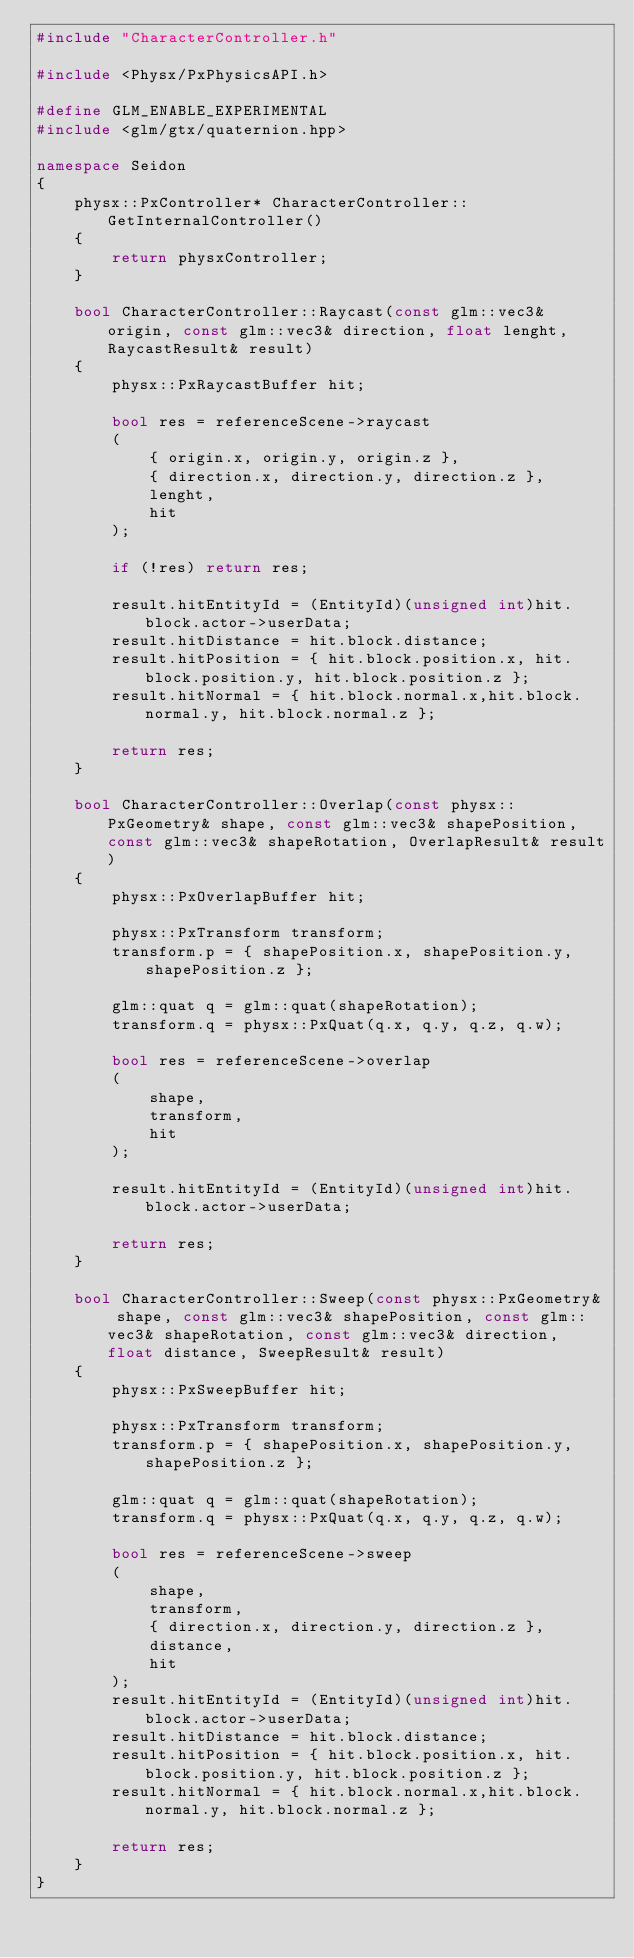<code> <loc_0><loc_0><loc_500><loc_500><_C++_>#include "CharacterController.h"

#include <Physx/PxPhysicsAPI.h>

#define GLM_ENABLE_EXPERIMENTAL
#include <glm/gtx/quaternion.hpp>

namespace Seidon
{
	physx::PxController* CharacterController::GetInternalController()
	{
		return physxController;
	}

	bool CharacterController::Raycast(const glm::vec3& origin, const glm::vec3& direction, float lenght, RaycastResult& result)
	{
		physx::PxRaycastBuffer hit;

		bool res = referenceScene->raycast
		(
			{ origin.x, origin.y, origin.z },
			{ direction.x, direction.y, direction.z },
			lenght,
			hit
		);

		if (!res) return res;

		result.hitEntityId = (EntityId)(unsigned int)hit.block.actor->userData;
		result.hitDistance = hit.block.distance;
		result.hitPosition = { hit.block.position.x, hit.block.position.y, hit.block.position.z };
		result.hitNormal = { hit.block.normal.x,hit.block.normal.y, hit.block.normal.z };

		return res;
	}

	bool CharacterController::Overlap(const physx::PxGeometry& shape, const glm::vec3& shapePosition, const glm::vec3& shapeRotation, OverlapResult& result)
	{
		physx::PxOverlapBuffer hit;

		physx::PxTransform transform;
		transform.p = { shapePosition.x, shapePosition.y, shapePosition.z };

		glm::quat q = glm::quat(shapeRotation);
		transform.q = physx::PxQuat(q.x, q.y, q.z, q.w);

		bool res = referenceScene->overlap
		(
			shape,
			transform,
			hit
		);

		result.hitEntityId = (EntityId)(unsigned int)hit.block.actor->userData;

		return res;
	}

	bool CharacterController::Sweep(const physx::PxGeometry& shape, const glm::vec3& shapePosition, const glm::vec3& shapeRotation, const glm::vec3& direction, float distance, SweepResult& result)
	{
		physx::PxSweepBuffer hit;

		physx::PxTransform transform;
		transform.p = { shapePosition.x, shapePosition.y, shapePosition.z };

		glm::quat q = glm::quat(shapeRotation);
		transform.q = physx::PxQuat(q.x, q.y, q.z, q.w);

		bool res = referenceScene->sweep
		(
			shape,
			transform,
			{ direction.x, direction.y, direction.z },
			distance,
			hit
		);
		result.hitEntityId = (EntityId)(unsigned int)hit.block.actor->userData;
		result.hitDistance = hit.block.distance;
		result.hitPosition = { hit.block.position.x, hit.block.position.y, hit.block.position.z };
		result.hitNormal = { hit.block.normal.x,hit.block.normal.y, hit.block.normal.z };

		return res;
	}
}</code> 